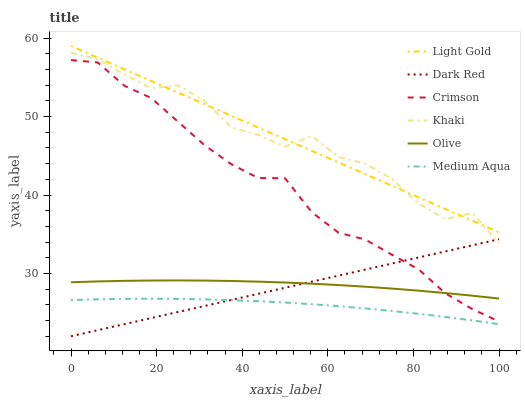Does Dark Red have the minimum area under the curve?
Answer yes or no. No. Does Dark Red have the maximum area under the curve?
Answer yes or no. No. Is Olive the smoothest?
Answer yes or no. No. Is Olive the roughest?
Answer yes or no. No. Does Olive have the lowest value?
Answer yes or no. No. Does Dark Red have the highest value?
Answer yes or no. No. Is Medium Aqua less than Light Gold?
Answer yes or no. Yes. Is Light Gold greater than Olive?
Answer yes or no. Yes. Does Medium Aqua intersect Light Gold?
Answer yes or no. No. 